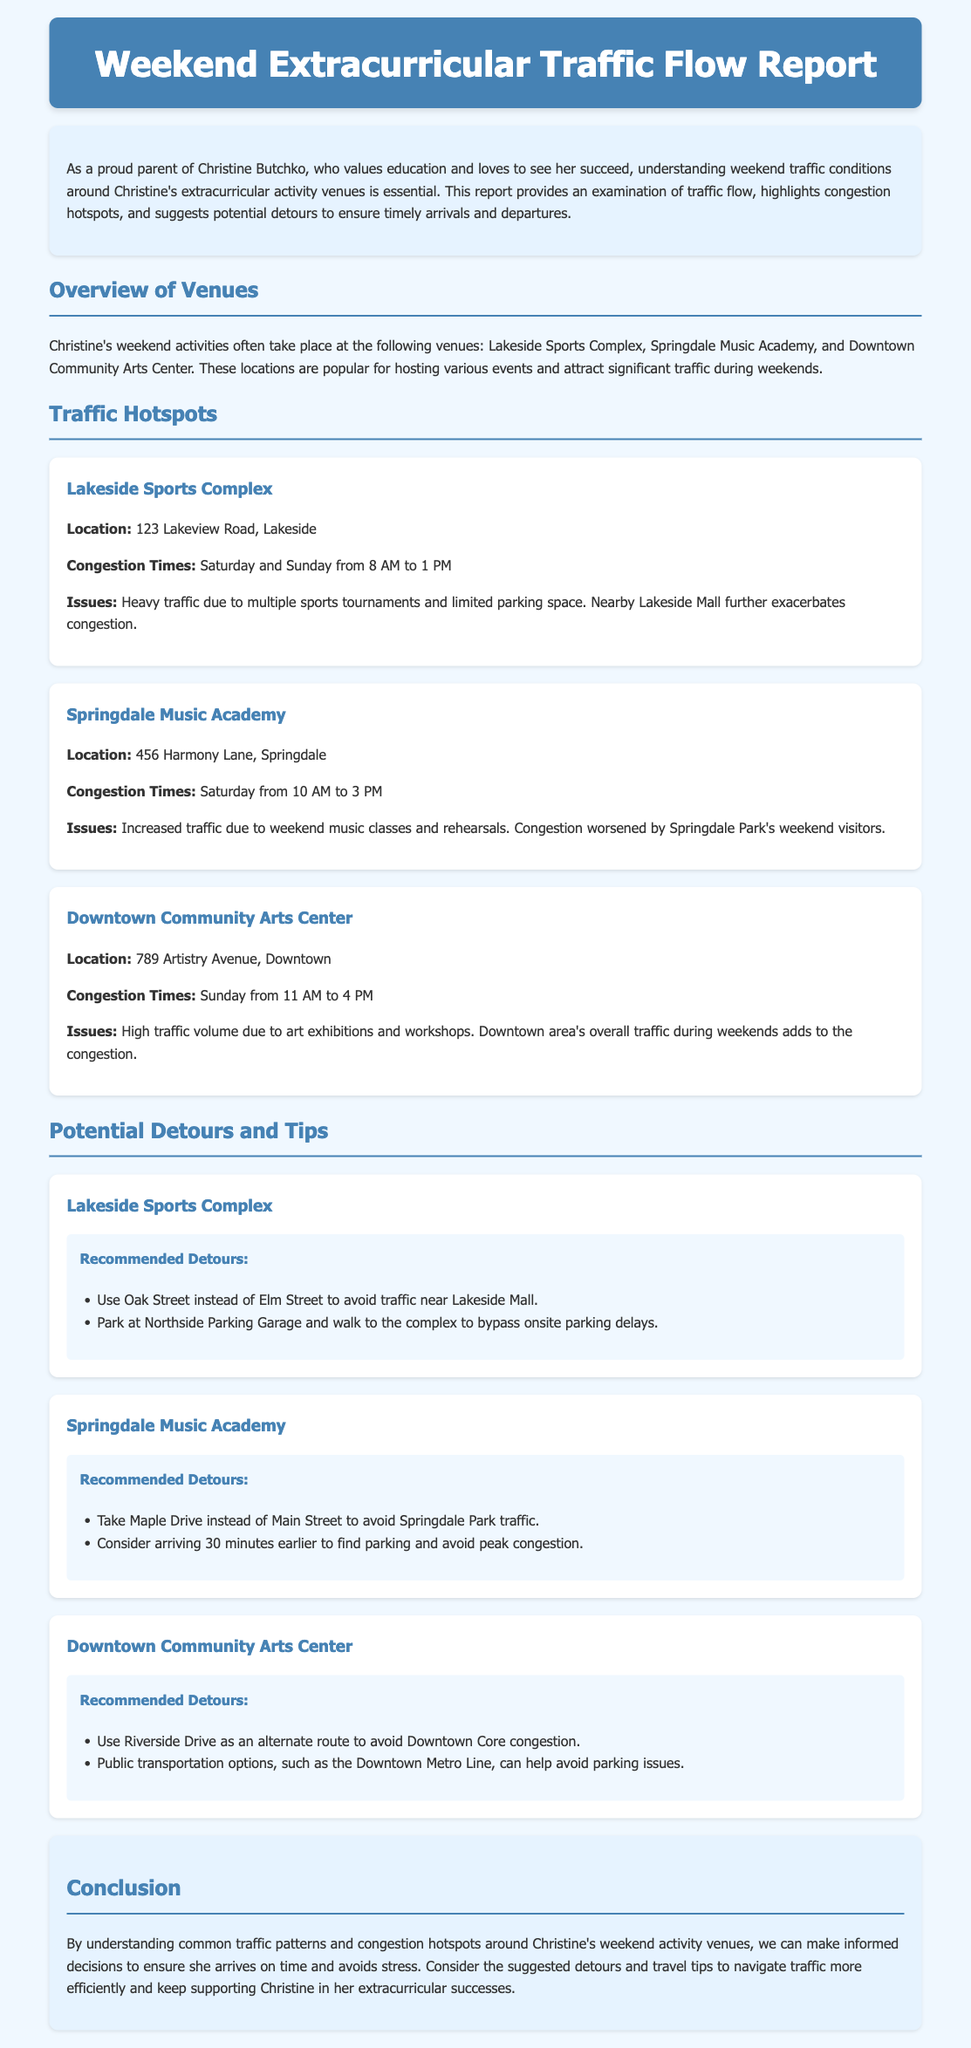What are the names of the venues? The document lists three venues: Lakeside Sports Complex, Springdale Music Academy, and Downtown Community Arts Center.
Answer: Lakeside Sports Complex, Springdale Music Academy, Downtown Community Arts Center What time does congestion peak at Lakeside Sports Complex? Congestion times at Lakeside Sports Complex are specified as Saturday and Sunday from 8 AM to 1 PM.
Answer: Saturday and Sunday from 8 AM to 1 PM What issue is noted at the Springdale Music Academy? The document states that increased traffic due to weekend music classes and rehearsals is an issue at the Springdale Music Academy.
Answer: Increased traffic due to weekend music classes and rehearsals Which street should be used to avoid traffic near Lakeside Mall? The report recommends using Oak Street instead of Elm Street to avoid traffic near Lakeside Mall.
Answer: Oak Street What is suggested to avoid peak congestion at Springdale Music Academy? Arriving 30 minutes earlier is suggested to find parking and avoid peak congestion at Springdale Music Academy.
Answer: Arriving 30 minutes earlier When does traffic peak at Downtown Community Arts Center? Traffic at Downtown Community Arts Center peaks on Sunday from 11 AM to 4 PM.
Answer: Sunday from 11 AM to 4 PM What is a recommended public transportation option for Downtown Community Arts Center? The document suggests using the Downtown Metro Line as a public transportation option.
Answer: Downtown Metro Line What type of report is this document categorized as? The document is categorized as a traffic report focusing on weekend extracurricular traffic flow.
Answer: Traffic report 